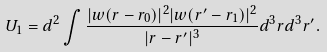Convert formula to latex. <formula><loc_0><loc_0><loc_500><loc_500>U _ { 1 } = d ^ { 2 } \int \frac { | w ( { r } - { r } _ { 0 } ) | ^ { 2 } | w ( { r } ^ { \prime } - { r } _ { 1 } ) | ^ { 2 } } { | { r } - { r } ^ { \prime } | ^ { 3 } } d ^ { 3 } r d ^ { 3 } r ^ { \prime } .</formula> 